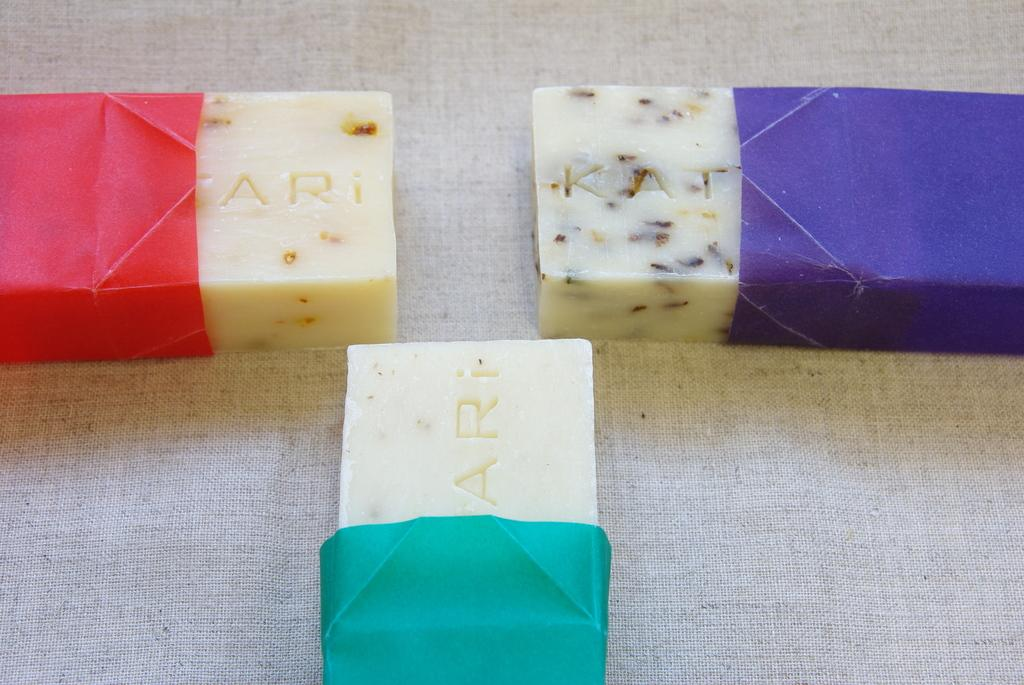What type of food items are present in the image? The image contains sweets. How can the wrappers of the sweets be distinguished from one another? The wrappers of the sweets are in different colors. What is located at the bottom of the image? There appears to be a cloth at the bottom of the image. What type of lumber is visible in the image? There is no lumber present in the image. What effect does the air have on the sweets in the image? The air does not have any visible effect on the sweets in the image; they are stationary. 